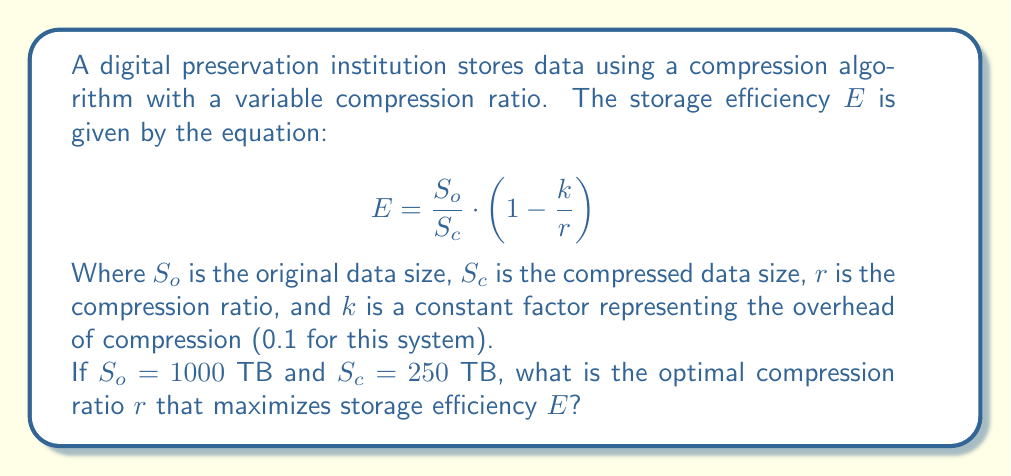Provide a solution to this math problem. To find the optimal compression ratio, we need to maximize the storage efficiency function $E$. Let's approach this step-by-step:

1) First, we can simplify the given equation by substituting the known values:
   $S_o = 1000$ TB, $S_c = 250$ TB, $k = 0.1$
   
   $$E = \frac{1000}{250} \cdot (1 - \frac{0.1}{r}) = 4 \cdot (1 - \frac{0.1}{r})$$

2) Now we have $E$ as a function of $r$:
   
   $$E(r) = 4 - \frac{0.4}{r}$$

3) To find the maximum value of $E$, we need to differentiate $E$ with respect to $r$ and set it to zero:

   $$\frac{dE}{dr} = \frac{0.4}{r^2}$$

4) Setting this to zero:
   
   $$\frac{0.4}{r^2} = 0$$

5) This equation is never satisfied for any finite $r$. This means that $E$ doesn't have a maximum value for any finite $r$.

6) As $r$ approaches infinity, $E$ approaches its upper limit of 4.

7) However, in practical terms, we can't have an infinite compression ratio. The actual compression ratio in this case is:

   $$r = \frac{S_o}{S_c} = \frac{1000}{250} = 4$$

8) This ratio of 4 is already achieving the maximum possible efficiency for this system, given the constraints.

Therefore, the optimal compression ratio is the current ratio of 4, as any higher ratio would be impractical or impossible to achieve.
Answer: 4 